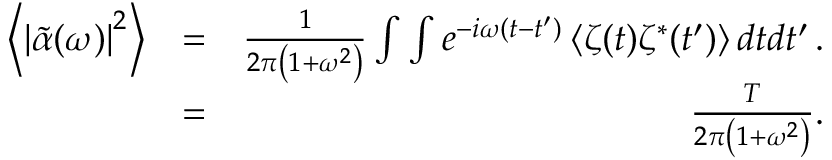<formula> <loc_0><loc_0><loc_500><loc_500>\begin{array} { r l r } { \left \langle \left | \tilde { \alpha } ( \omega ) \right | ^ { 2 } \right \rangle } & { = } & { \frac { 1 } { 2 \pi \left ( 1 + \omega ^ { 2 } \right ) } \int \int e ^ { - i \omega ( t - t ^ { \prime } ) } \left \langle \zeta ( t ) \zeta ^ { * } ( t ^ { \prime } ) \right \rangle d t d t ^ { \prime } \, . } \\ & { = } & { \frac { T } { 2 \pi \left ( 1 + \omega ^ { 2 } \right ) } . } \end{array}</formula> 